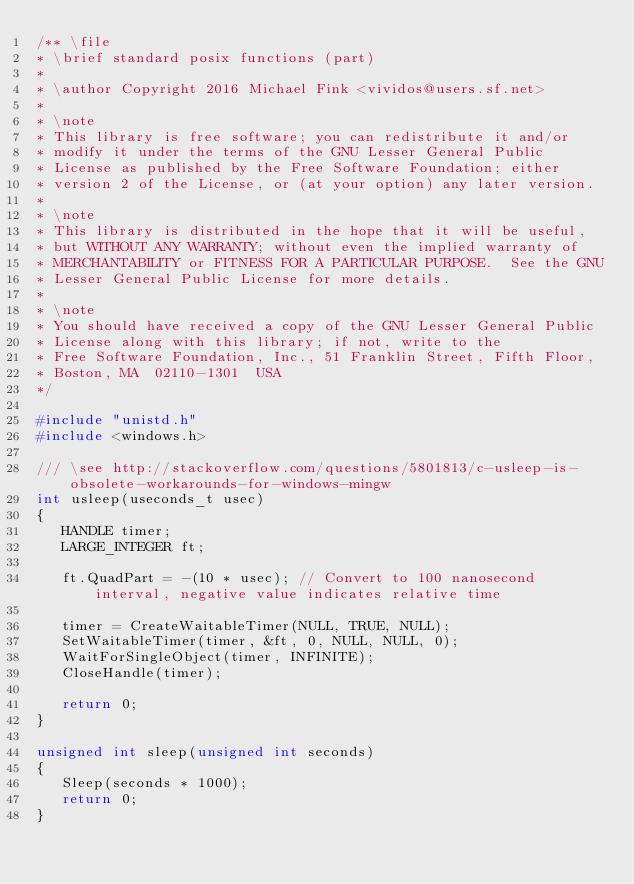Convert code to text. <code><loc_0><loc_0><loc_500><loc_500><_C_>/** \file
* \brief standard posix functions (part)
*
* \author Copyright 2016 Michael Fink <vividos@users.sf.net>
*
* \note
* This library is free software; you can redistribute it and/or
* modify it under the terms of the GNU Lesser General Public
* License as published by the Free Software Foundation; either
* version 2 of the License, or (at your option) any later version.
*
* \note
* This library is distributed in the hope that it will be useful,
* but WITHOUT ANY WARRANTY; without even the implied warranty of
* MERCHANTABILITY or FITNESS FOR A PARTICULAR PURPOSE.  See the GNU
* Lesser General Public License for more details.
*
* \note
* You should have received a copy of the GNU Lesser General Public
* License along with this library; if not, write to the
* Free Software Foundation, Inc., 51 Franklin Street, Fifth Floor,
* Boston, MA  02110-1301  USA
*/

#include "unistd.h"
#include <windows.h>

/// \see http://stackoverflow.com/questions/5801813/c-usleep-is-obsolete-workarounds-for-windows-mingw
int usleep(useconds_t usec)
{
   HANDLE timer;
   LARGE_INTEGER ft;

   ft.QuadPart = -(10 * usec); // Convert to 100 nanosecond interval, negative value indicates relative time

   timer = CreateWaitableTimer(NULL, TRUE, NULL);
   SetWaitableTimer(timer, &ft, 0, NULL, NULL, 0);
   WaitForSingleObject(timer, INFINITE);
   CloseHandle(timer);

   return 0;
}

unsigned int sleep(unsigned int seconds)
{
   Sleep(seconds * 1000);
   return 0;
}
</code> 